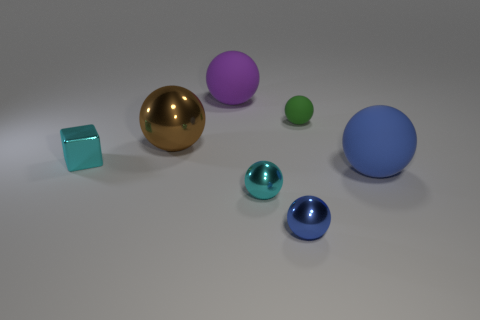Subtract all cyan spheres. How many spheres are left? 5 Subtract all blue balls. How many balls are left? 4 Subtract 3 balls. How many balls are left? 3 Subtract all purple spheres. Subtract all brown cubes. How many spheres are left? 5 Add 3 brown things. How many objects exist? 10 Subtract all spheres. How many objects are left? 1 Add 7 small green matte blocks. How many small green matte blocks exist? 7 Subtract 0 red cubes. How many objects are left? 7 Subtract all small gray metallic cylinders. Subtract all brown metallic things. How many objects are left? 6 Add 5 tiny metallic objects. How many tiny metallic objects are left? 8 